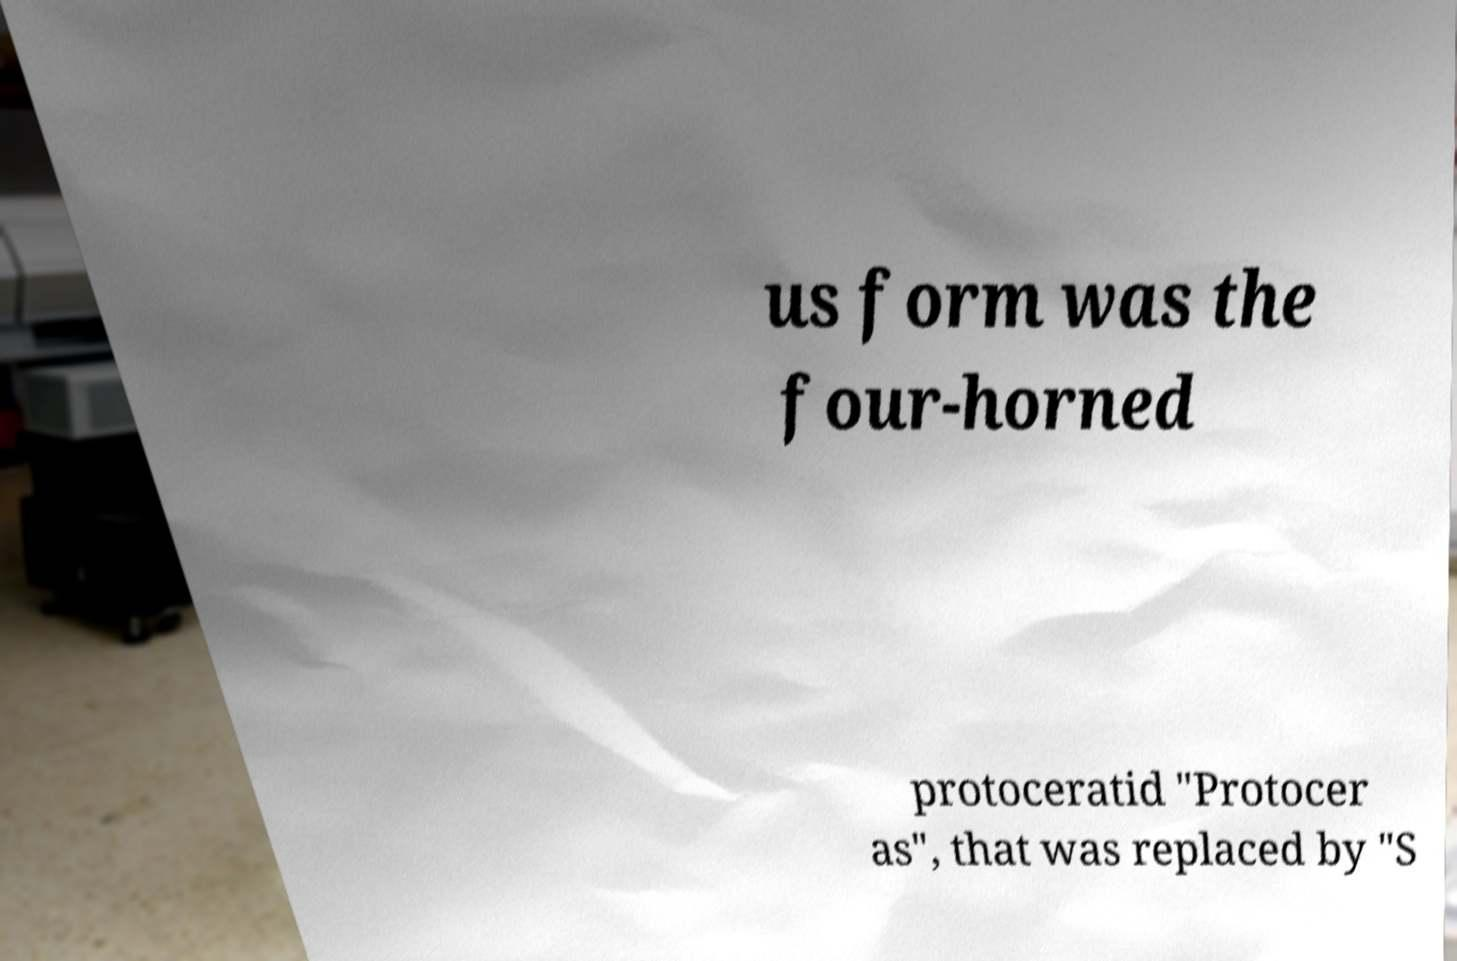What messages or text are displayed in this image? I need them in a readable, typed format. us form was the four-horned protoceratid "Protocer as", that was replaced by "S 